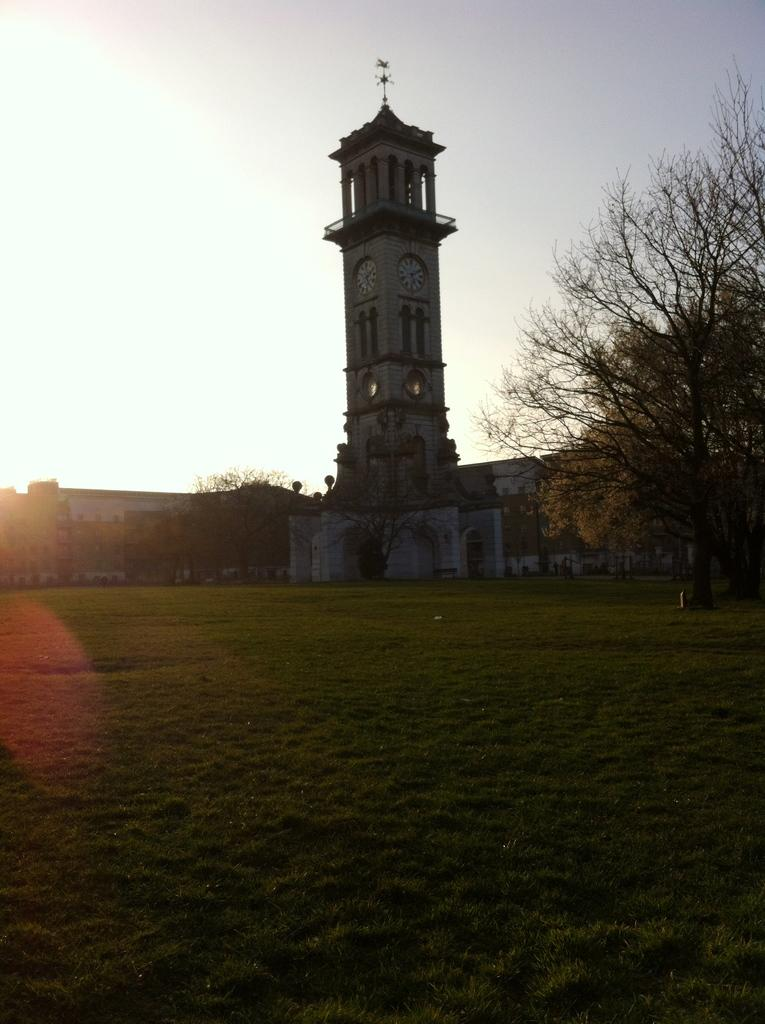What type of ground surface is visible in the image? There is grass on the ground in the image. What can be seen in the background of the image? There are trees and buildings in the background. What architectural feature is present in the image? There is a tower with arches, pillars, and clocks. What part of the natural environment is visible in the image? The sky is visible in the background. Is there any quicksand visible in the image? No, there is no quicksand present in the image. Can you see any trails or paths in the image? There is no mention of trails or paths in the provided facts, so we cannot determine their presence from the image. 